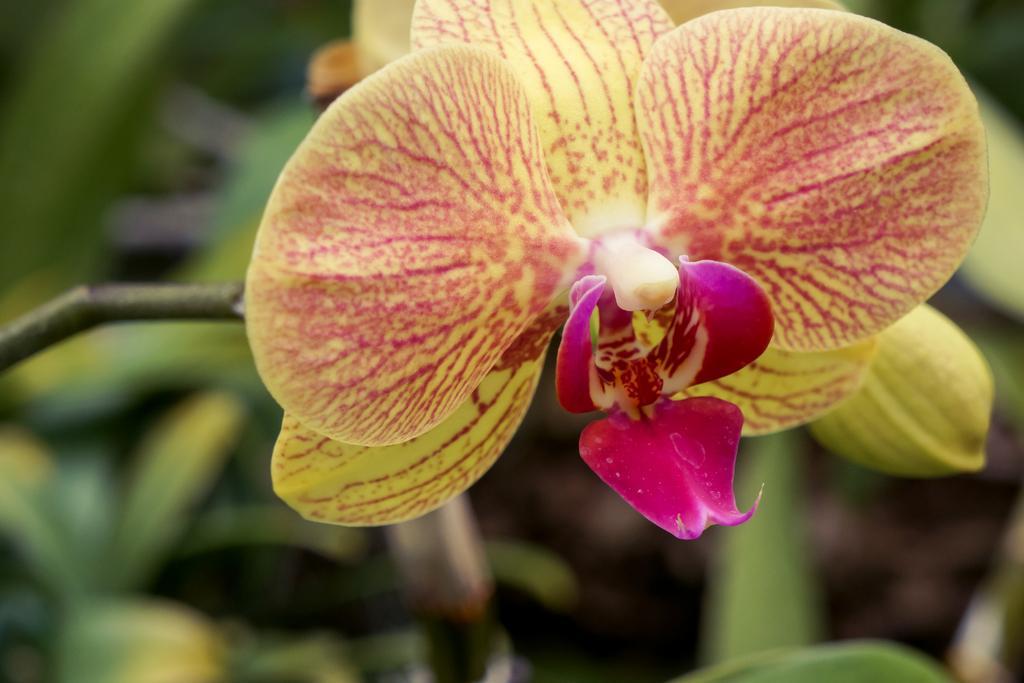In one or two sentences, can you explain what this image depicts? This image is taken outdoors. In this image the background is a little blurred. There are a few leaves. In the middle of the image there is a plant with leaves, stems and there is a flower which is light yellow and pink in colors. 